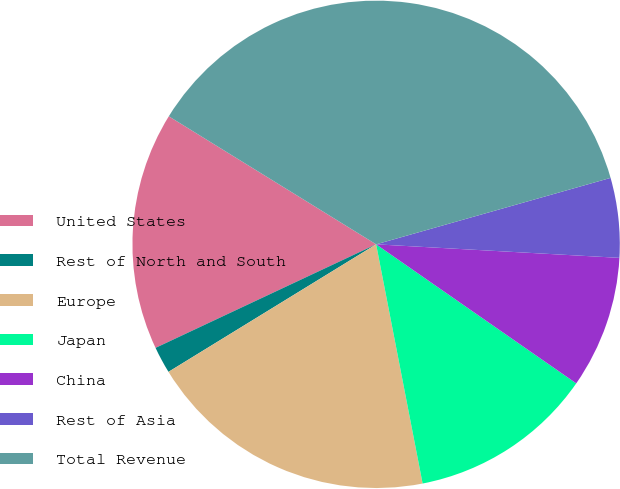<chart> <loc_0><loc_0><loc_500><loc_500><pie_chart><fcel>United States<fcel>Rest of North and South<fcel>Europe<fcel>Japan<fcel>China<fcel>Rest of Asia<fcel>Total Revenue<nl><fcel>15.79%<fcel>1.78%<fcel>19.29%<fcel>12.28%<fcel>8.78%<fcel>5.28%<fcel>36.8%<nl></chart> 